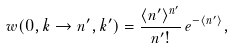<formula> <loc_0><loc_0><loc_500><loc_500>w ( 0 , k \rightarrow n ^ { \prime } , k ^ { \prime } ) = \frac { \langle n ^ { \prime } \rangle ^ { n ^ { \prime } } } { n ^ { \prime } ! } \, e ^ { - \langle n ^ { \prime } \rangle } ,</formula> 